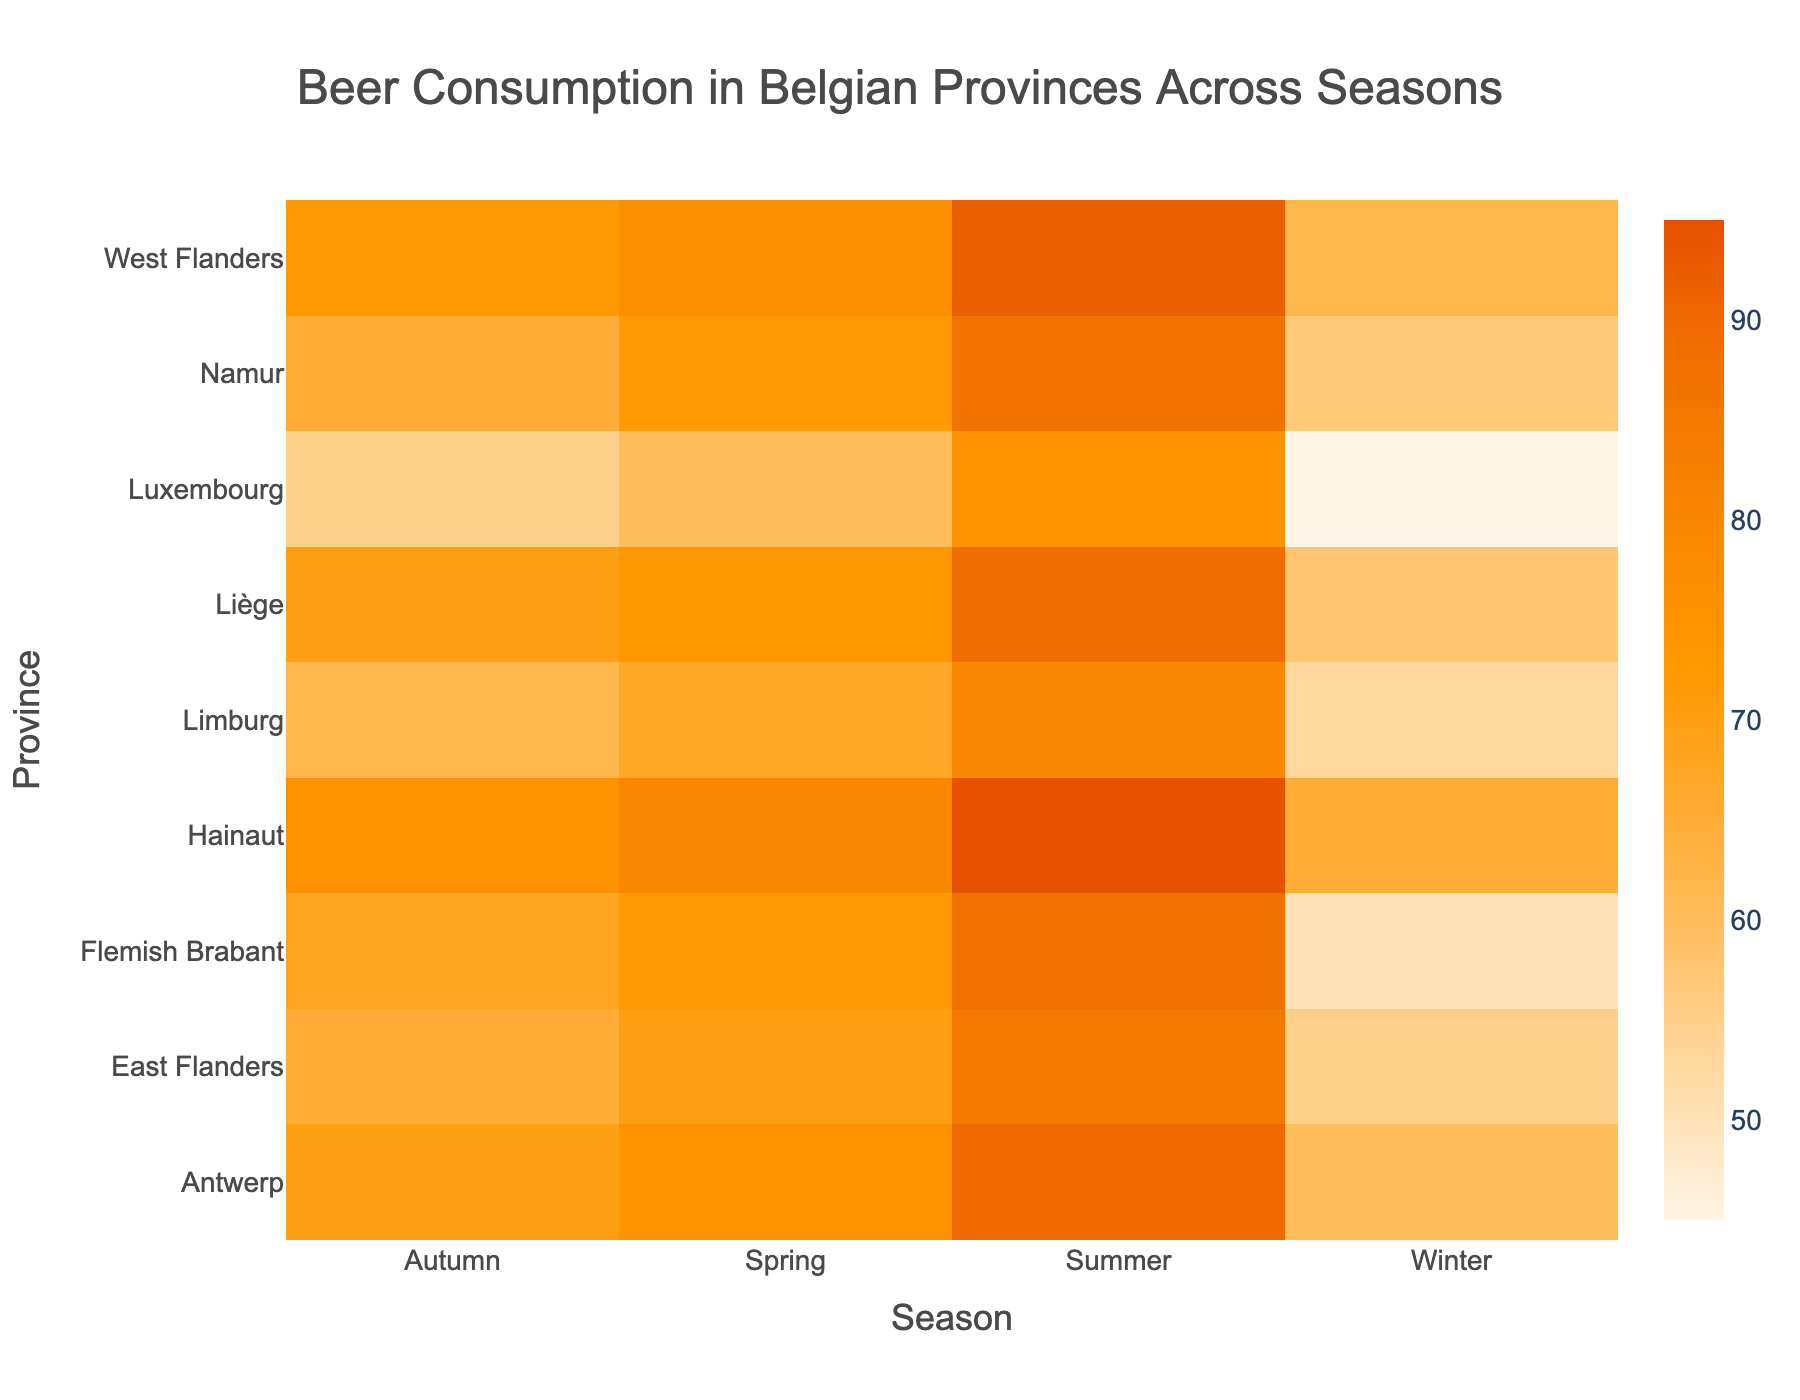what's the title of the heatmap? The title of the heatmap is at the top center of the figure. It reads "Beer Consumption in Belgian Provinces Across Seasons".
Answer: Beer Consumption in Belgian Provinces Across Seasons which province has the highest beer consumption in summer? Look at the row labeled "Summer" and find the highest value. The highest value in the summer row is 95 liters in the "Hainaut" column.
Answer: Hainaut compare the beer consumption in summer and winter for Antwerp. Which season has higher consumption, and by how much? For Antwerp, the beer consumption in summer is 90 liters, and in winter, it is 60 liters. Subtract the winter value from the summer value (90 - 60).
Answer: Summer has higher consumption by 30 liters what is the average beer consumption in East Flanders across all seasons? Find the values for East Flanders in all seasons: Winter (55), Spring (70), Summer (85), Autumn (65). Sum these values (55 + 70 + 85 + 65 = 275) and divide by the number of seasons (4).
Answer: 68.75 liters what season has the highest average beer consumption across all provinces? Look at each column (Season) and calculate the averages. Add the values in each season and divide by the number of provinces (Winter: (60+55+50+65+58+53+45+57+62)/9 = 56.11, Spring: (75+70+72+80+73+67+60+72+77)/9 = 72.89, Summer: (90+85+88+95+89+80+75+87+92)/9 = 86.56, Autumn: (70+65+68+75+70+62+55+65+72)/9 = 66.89). Compare the averages.
Answer: Summer are there any provinces with the same beer consumption levels in multiple seasons? Look at each row to find any repeated values within a province. No province has the same beer consumption levels in multiple seasons.
Answer: No what province has the lowest overall beer consumption, and in which season does it occur? Identify the smallest value in the entire heatmap. The smallest value is 45 liters, which occurs in the "Luxembourg" province during "Winter".
Answer: Luxembourg in Winter which province shows the least variation in beer consumption across seasons? Calculate the range (max - min) of beer consumption for each province and compare. For example, Antwerp: 90 - 60 = 30, East Flanders: 85 - 55 = 30, (continue this for all provinces). Province "Luxembourg" has the smallest range (75 - 45 = 30).
Answer: Luxembourg how does beer consumption in Winter in Hainaut compare with Summer in Limburg? Hainaut in Winter has 65 liters, and Limburg in Summer has 80 liters. Compare the two numbers (65 < 80).
Answer: Limburg in Summer has higher consumption by 15 liters is the correlation between the season and beer consumption the same in all provinces? Visually inspect the general trend or pattern of beer consumption with seasons for each province. Identify if there are consistent patterns like higher consumption in Summer across most provinces, even if the exact numbers differ.
Answer: Yes, the general trend shows higher consumption in Summer across most provinces 